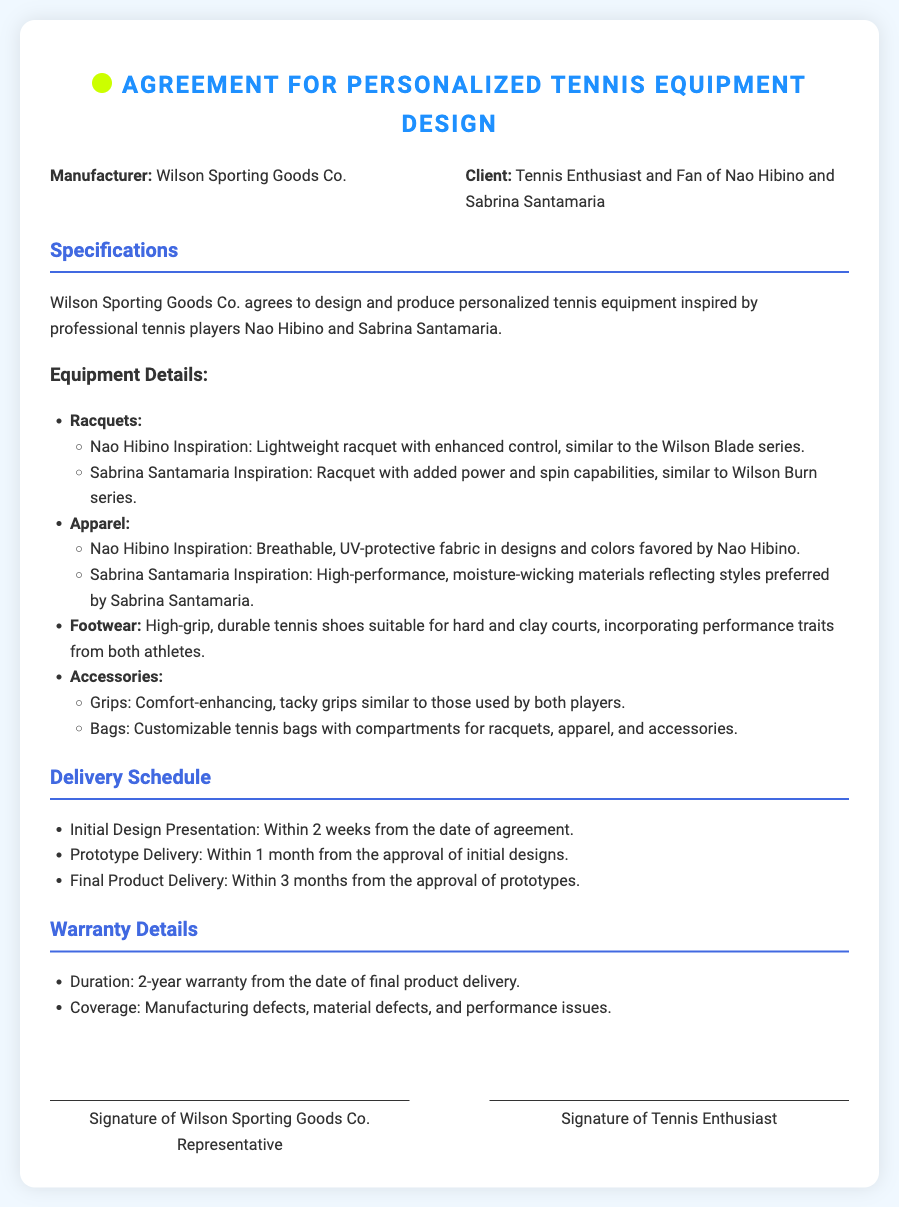What is the manufacturer’s name? The manufacturer is specifically mentioned as Wilson Sporting Goods Co. in the document.
Answer: Wilson Sporting Goods Co Who is the client? The document states that the client is described as "Tennis Enthusiast and Fan of Nao Hibino and Sabrina Santamaria."
Answer: Tennis Enthusiast and Fan of Nao Hibino and Sabrina Santamaria What is the warranty duration? The document specifies a warranty duration of 2 years from the date of final product delivery.
Answer: 2 years When is the initial design presentation scheduled? The agreement states that the initial design presentation will occur within 2 weeks from the date of agreement.
Answer: Within 2 weeks What type of shoes are specified for the equipment? The document describes the footwear as high-grip, durable tennis shoes suitable for hard and clay courts.
Answer: High-grip, durable tennis shoes What is the delivery timeframe for the final product? According to the document, the final product delivery is scheduled to be within 3 months from the approval of prototypes.
Answer: Within 3 months Which racquet series is inspired by Nao Hibino? The equipment details mention a lightweight racquet with enhanced control, similar to the Wilson Blade series, inspired by Nao Hibino.
Answer: Wilson Blade series What types of accessories are included? The document lists grips and bags as the accessories included in the personalized equipment.
Answer: Grips and bags What kind of fabrics are used for Nao Hibino-inspired apparel? The document states that the fabric is breathable, UV-protective in designs and colors favored by Nao Hibino.
Answer: Breathable, UV-protective fabric 